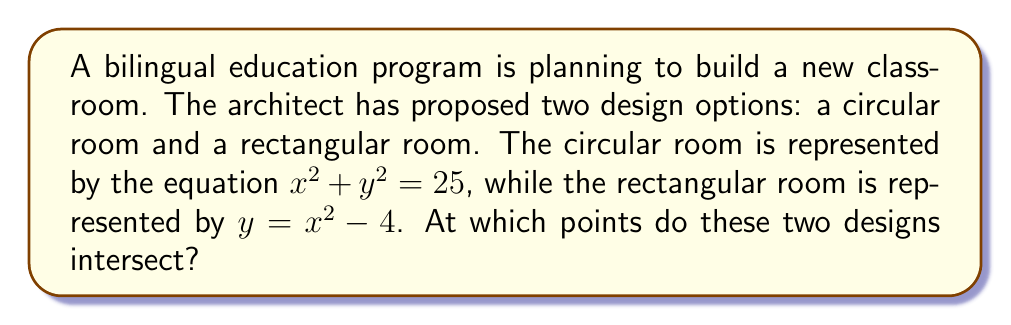Teach me how to tackle this problem. To find the intersection points of these two curves, we need to solve the system of equations:

1) $x^2 + y^2 = 25$ (Circle equation)
2) $y = x^2 - 4$ (Parabola equation)

Step 1: Substitute equation (2) into equation (1):
$x^2 + (x^2 - 4)^2 = 25$

Step 2: Expand the equation:
$x^2 + x^4 - 8x^2 + 16 = 25$

Step 3: Simplify:
$x^4 - 7x^2 - 9 = 0$

Step 4: This is a quadratic equation in $x^2$. Let $u = x^2$:
$u^2 - 7u - 9 = 0$

Step 5: Solve this quadratic equation using the quadratic formula:
$u = \frac{7 \pm \sqrt{49 + 36}}{2} = \frac{7 \pm \sqrt{85}}{2}$

Step 6: Substitute back $x^2 = u$:
$x^2 = \frac{7 + \sqrt{85}}{2}$ or $x^2 = \frac{7 - \sqrt{85}}{2}$

Step 7: Solve for x:
$x = \pm \sqrt{\frac{7 + \sqrt{85}}{2}}$ (we discard the negative solution as it's not real)

Step 8: Calculate y using equation (2):
$y = (\frac{7 + \sqrt{85}}{2}) - 4 = \frac{-1 + \sqrt{85}}{2}$

Therefore, the intersection points are:
$(\sqrt{\frac{7 + \sqrt{85}}{2}}, \frac{-1 + \sqrt{85}}{2})$ and $(-\sqrt{\frac{7 + \sqrt{85}}{2}}, \frac{-1 + \sqrt{85}}{2})$
Answer: $(\pm\sqrt{\frac{7 + \sqrt{85}}{2}}, \frac{-1 + \sqrt{85}}{2})$ 